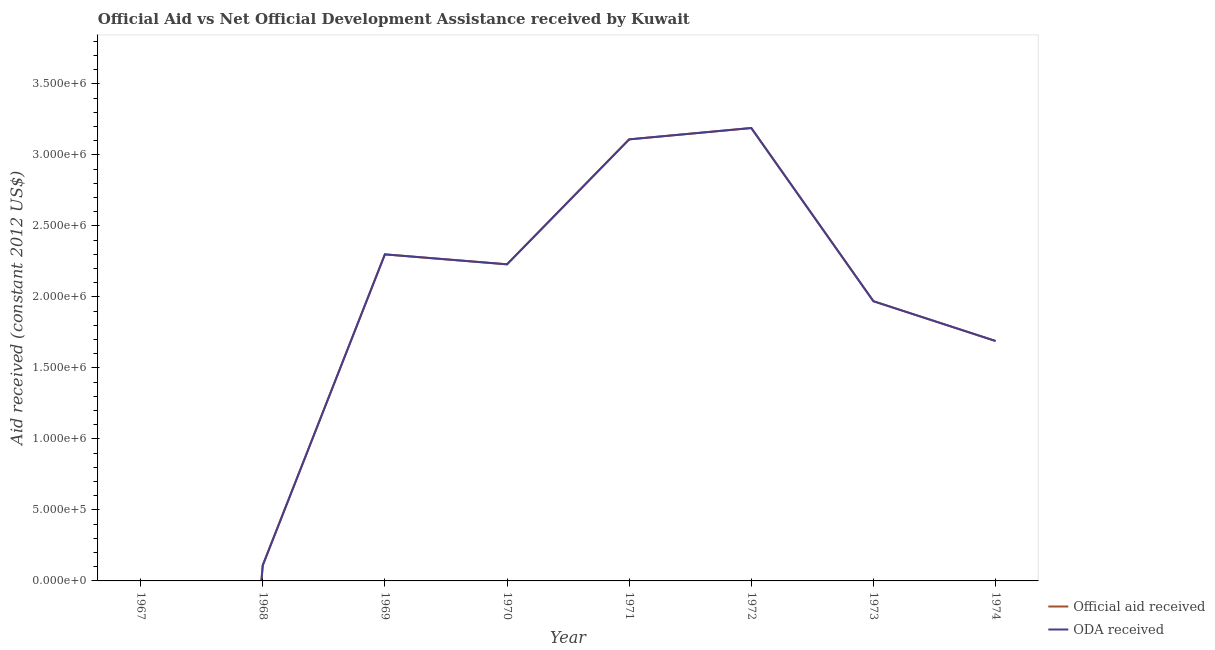How many different coloured lines are there?
Offer a very short reply. 2. Does the line corresponding to official aid received intersect with the line corresponding to oda received?
Offer a terse response. Yes. What is the official aid received in 1972?
Provide a succinct answer. 3.19e+06. Across all years, what is the maximum oda received?
Offer a terse response. 3.19e+06. Across all years, what is the minimum oda received?
Offer a terse response. 0. In which year was the official aid received maximum?
Keep it short and to the point. 1972. What is the total official aid received in the graph?
Your answer should be compact. 1.46e+07. What is the difference between the official aid received in 1970 and that in 1971?
Give a very brief answer. -8.80e+05. What is the difference between the oda received in 1974 and the official aid received in 1972?
Your response must be concise. -1.50e+06. What is the average oda received per year?
Ensure brevity in your answer.  1.82e+06. In the year 1970, what is the difference between the oda received and official aid received?
Your answer should be compact. 0. In how many years, is the official aid received greater than 2000000 US$?
Your answer should be very brief. 4. What is the ratio of the official aid received in 1968 to that in 1973?
Offer a terse response. 0.06. Is the official aid received in 1970 less than that in 1974?
Ensure brevity in your answer.  No. Is the difference between the oda received in 1970 and 1973 greater than the difference between the official aid received in 1970 and 1973?
Give a very brief answer. No. What is the difference between the highest and the second highest oda received?
Your answer should be compact. 8.00e+04. What is the difference between the highest and the lowest official aid received?
Your answer should be compact. 3.19e+06. Is the sum of the oda received in 1968 and 1973 greater than the maximum official aid received across all years?
Offer a very short reply. No. Is the official aid received strictly greater than the oda received over the years?
Your answer should be compact. No. How many lines are there?
Your answer should be very brief. 2. How many years are there in the graph?
Your response must be concise. 8. What is the difference between two consecutive major ticks on the Y-axis?
Ensure brevity in your answer.  5.00e+05. Does the graph contain any zero values?
Your answer should be very brief. Yes. Does the graph contain grids?
Your answer should be compact. No. Where does the legend appear in the graph?
Your answer should be very brief. Bottom right. How many legend labels are there?
Offer a terse response. 2. How are the legend labels stacked?
Make the answer very short. Vertical. What is the title of the graph?
Provide a succinct answer. Official Aid vs Net Official Development Assistance received by Kuwait . What is the label or title of the X-axis?
Offer a very short reply. Year. What is the label or title of the Y-axis?
Keep it short and to the point. Aid received (constant 2012 US$). What is the Aid received (constant 2012 US$) of Official aid received in 1967?
Offer a terse response. 0. What is the Aid received (constant 2012 US$) of Official aid received in 1969?
Make the answer very short. 2.30e+06. What is the Aid received (constant 2012 US$) in ODA received in 1969?
Offer a terse response. 2.30e+06. What is the Aid received (constant 2012 US$) of Official aid received in 1970?
Your answer should be very brief. 2.23e+06. What is the Aid received (constant 2012 US$) of ODA received in 1970?
Offer a terse response. 2.23e+06. What is the Aid received (constant 2012 US$) in Official aid received in 1971?
Keep it short and to the point. 3.11e+06. What is the Aid received (constant 2012 US$) in ODA received in 1971?
Ensure brevity in your answer.  3.11e+06. What is the Aid received (constant 2012 US$) in Official aid received in 1972?
Keep it short and to the point. 3.19e+06. What is the Aid received (constant 2012 US$) in ODA received in 1972?
Provide a short and direct response. 3.19e+06. What is the Aid received (constant 2012 US$) of Official aid received in 1973?
Offer a very short reply. 1.97e+06. What is the Aid received (constant 2012 US$) in ODA received in 1973?
Give a very brief answer. 1.97e+06. What is the Aid received (constant 2012 US$) in Official aid received in 1974?
Your answer should be compact. 1.69e+06. What is the Aid received (constant 2012 US$) of ODA received in 1974?
Keep it short and to the point. 1.69e+06. Across all years, what is the maximum Aid received (constant 2012 US$) in Official aid received?
Keep it short and to the point. 3.19e+06. Across all years, what is the maximum Aid received (constant 2012 US$) of ODA received?
Ensure brevity in your answer.  3.19e+06. Across all years, what is the minimum Aid received (constant 2012 US$) in ODA received?
Offer a very short reply. 0. What is the total Aid received (constant 2012 US$) in Official aid received in the graph?
Give a very brief answer. 1.46e+07. What is the total Aid received (constant 2012 US$) in ODA received in the graph?
Your answer should be compact. 1.46e+07. What is the difference between the Aid received (constant 2012 US$) in Official aid received in 1968 and that in 1969?
Give a very brief answer. -2.19e+06. What is the difference between the Aid received (constant 2012 US$) of ODA received in 1968 and that in 1969?
Your answer should be very brief. -2.19e+06. What is the difference between the Aid received (constant 2012 US$) in Official aid received in 1968 and that in 1970?
Make the answer very short. -2.12e+06. What is the difference between the Aid received (constant 2012 US$) of ODA received in 1968 and that in 1970?
Make the answer very short. -2.12e+06. What is the difference between the Aid received (constant 2012 US$) of Official aid received in 1968 and that in 1971?
Keep it short and to the point. -3.00e+06. What is the difference between the Aid received (constant 2012 US$) in ODA received in 1968 and that in 1971?
Offer a very short reply. -3.00e+06. What is the difference between the Aid received (constant 2012 US$) in Official aid received in 1968 and that in 1972?
Provide a short and direct response. -3.08e+06. What is the difference between the Aid received (constant 2012 US$) of ODA received in 1968 and that in 1972?
Your answer should be very brief. -3.08e+06. What is the difference between the Aid received (constant 2012 US$) of Official aid received in 1968 and that in 1973?
Your answer should be compact. -1.86e+06. What is the difference between the Aid received (constant 2012 US$) of ODA received in 1968 and that in 1973?
Provide a succinct answer. -1.86e+06. What is the difference between the Aid received (constant 2012 US$) of Official aid received in 1968 and that in 1974?
Make the answer very short. -1.58e+06. What is the difference between the Aid received (constant 2012 US$) in ODA received in 1968 and that in 1974?
Make the answer very short. -1.58e+06. What is the difference between the Aid received (constant 2012 US$) of Official aid received in 1969 and that in 1970?
Your answer should be very brief. 7.00e+04. What is the difference between the Aid received (constant 2012 US$) of ODA received in 1969 and that in 1970?
Keep it short and to the point. 7.00e+04. What is the difference between the Aid received (constant 2012 US$) in Official aid received in 1969 and that in 1971?
Offer a very short reply. -8.10e+05. What is the difference between the Aid received (constant 2012 US$) of ODA received in 1969 and that in 1971?
Ensure brevity in your answer.  -8.10e+05. What is the difference between the Aid received (constant 2012 US$) of Official aid received in 1969 and that in 1972?
Provide a short and direct response. -8.90e+05. What is the difference between the Aid received (constant 2012 US$) of ODA received in 1969 and that in 1972?
Your answer should be very brief. -8.90e+05. What is the difference between the Aid received (constant 2012 US$) of Official aid received in 1969 and that in 1973?
Your answer should be very brief. 3.30e+05. What is the difference between the Aid received (constant 2012 US$) of ODA received in 1969 and that in 1973?
Your response must be concise. 3.30e+05. What is the difference between the Aid received (constant 2012 US$) in ODA received in 1969 and that in 1974?
Provide a short and direct response. 6.10e+05. What is the difference between the Aid received (constant 2012 US$) in Official aid received in 1970 and that in 1971?
Offer a very short reply. -8.80e+05. What is the difference between the Aid received (constant 2012 US$) of ODA received in 1970 and that in 1971?
Provide a succinct answer. -8.80e+05. What is the difference between the Aid received (constant 2012 US$) in Official aid received in 1970 and that in 1972?
Provide a succinct answer. -9.60e+05. What is the difference between the Aid received (constant 2012 US$) of ODA received in 1970 and that in 1972?
Offer a terse response. -9.60e+05. What is the difference between the Aid received (constant 2012 US$) of Official aid received in 1970 and that in 1974?
Keep it short and to the point. 5.40e+05. What is the difference between the Aid received (constant 2012 US$) in ODA received in 1970 and that in 1974?
Provide a short and direct response. 5.40e+05. What is the difference between the Aid received (constant 2012 US$) of Official aid received in 1971 and that in 1972?
Keep it short and to the point. -8.00e+04. What is the difference between the Aid received (constant 2012 US$) of ODA received in 1971 and that in 1972?
Your answer should be compact. -8.00e+04. What is the difference between the Aid received (constant 2012 US$) in Official aid received in 1971 and that in 1973?
Offer a very short reply. 1.14e+06. What is the difference between the Aid received (constant 2012 US$) of ODA received in 1971 and that in 1973?
Make the answer very short. 1.14e+06. What is the difference between the Aid received (constant 2012 US$) of Official aid received in 1971 and that in 1974?
Offer a terse response. 1.42e+06. What is the difference between the Aid received (constant 2012 US$) of ODA received in 1971 and that in 1974?
Offer a very short reply. 1.42e+06. What is the difference between the Aid received (constant 2012 US$) in Official aid received in 1972 and that in 1973?
Provide a succinct answer. 1.22e+06. What is the difference between the Aid received (constant 2012 US$) of ODA received in 1972 and that in 1973?
Offer a terse response. 1.22e+06. What is the difference between the Aid received (constant 2012 US$) in Official aid received in 1972 and that in 1974?
Give a very brief answer. 1.50e+06. What is the difference between the Aid received (constant 2012 US$) in ODA received in 1972 and that in 1974?
Ensure brevity in your answer.  1.50e+06. What is the difference between the Aid received (constant 2012 US$) in Official aid received in 1968 and the Aid received (constant 2012 US$) in ODA received in 1969?
Keep it short and to the point. -2.19e+06. What is the difference between the Aid received (constant 2012 US$) in Official aid received in 1968 and the Aid received (constant 2012 US$) in ODA received in 1970?
Your answer should be compact. -2.12e+06. What is the difference between the Aid received (constant 2012 US$) in Official aid received in 1968 and the Aid received (constant 2012 US$) in ODA received in 1972?
Your answer should be compact. -3.08e+06. What is the difference between the Aid received (constant 2012 US$) in Official aid received in 1968 and the Aid received (constant 2012 US$) in ODA received in 1973?
Provide a succinct answer. -1.86e+06. What is the difference between the Aid received (constant 2012 US$) of Official aid received in 1968 and the Aid received (constant 2012 US$) of ODA received in 1974?
Ensure brevity in your answer.  -1.58e+06. What is the difference between the Aid received (constant 2012 US$) of Official aid received in 1969 and the Aid received (constant 2012 US$) of ODA received in 1971?
Provide a short and direct response. -8.10e+05. What is the difference between the Aid received (constant 2012 US$) in Official aid received in 1969 and the Aid received (constant 2012 US$) in ODA received in 1972?
Your answer should be compact. -8.90e+05. What is the difference between the Aid received (constant 2012 US$) in Official aid received in 1970 and the Aid received (constant 2012 US$) in ODA received in 1971?
Your answer should be compact. -8.80e+05. What is the difference between the Aid received (constant 2012 US$) in Official aid received in 1970 and the Aid received (constant 2012 US$) in ODA received in 1972?
Keep it short and to the point. -9.60e+05. What is the difference between the Aid received (constant 2012 US$) in Official aid received in 1970 and the Aid received (constant 2012 US$) in ODA received in 1973?
Your response must be concise. 2.60e+05. What is the difference between the Aid received (constant 2012 US$) in Official aid received in 1970 and the Aid received (constant 2012 US$) in ODA received in 1974?
Offer a terse response. 5.40e+05. What is the difference between the Aid received (constant 2012 US$) of Official aid received in 1971 and the Aid received (constant 2012 US$) of ODA received in 1972?
Provide a succinct answer. -8.00e+04. What is the difference between the Aid received (constant 2012 US$) of Official aid received in 1971 and the Aid received (constant 2012 US$) of ODA received in 1973?
Your answer should be very brief. 1.14e+06. What is the difference between the Aid received (constant 2012 US$) in Official aid received in 1971 and the Aid received (constant 2012 US$) in ODA received in 1974?
Make the answer very short. 1.42e+06. What is the difference between the Aid received (constant 2012 US$) of Official aid received in 1972 and the Aid received (constant 2012 US$) of ODA received in 1973?
Your answer should be very brief. 1.22e+06. What is the difference between the Aid received (constant 2012 US$) in Official aid received in 1972 and the Aid received (constant 2012 US$) in ODA received in 1974?
Your response must be concise. 1.50e+06. What is the difference between the Aid received (constant 2012 US$) of Official aid received in 1973 and the Aid received (constant 2012 US$) of ODA received in 1974?
Ensure brevity in your answer.  2.80e+05. What is the average Aid received (constant 2012 US$) of Official aid received per year?
Offer a terse response. 1.82e+06. What is the average Aid received (constant 2012 US$) in ODA received per year?
Keep it short and to the point. 1.82e+06. In the year 1968, what is the difference between the Aid received (constant 2012 US$) in Official aid received and Aid received (constant 2012 US$) in ODA received?
Provide a succinct answer. 0. In the year 1969, what is the difference between the Aid received (constant 2012 US$) of Official aid received and Aid received (constant 2012 US$) of ODA received?
Provide a short and direct response. 0. In the year 1970, what is the difference between the Aid received (constant 2012 US$) of Official aid received and Aid received (constant 2012 US$) of ODA received?
Your answer should be very brief. 0. In the year 1971, what is the difference between the Aid received (constant 2012 US$) of Official aid received and Aid received (constant 2012 US$) of ODA received?
Provide a short and direct response. 0. What is the ratio of the Aid received (constant 2012 US$) of Official aid received in 1968 to that in 1969?
Provide a short and direct response. 0.05. What is the ratio of the Aid received (constant 2012 US$) in ODA received in 1968 to that in 1969?
Your response must be concise. 0.05. What is the ratio of the Aid received (constant 2012 US$) of Official aid received in 1968 to that in 1970?
Ensure brevity in your answer.  0.05. What is the ratio of the Aid received (constant 2012 US$) of ODA received in 1968 to that in 1970?
Keep it short and to the point. 0.05. What is the ratio of the Aid received (constant 2012 US$) of Official aid received in 1968 to that in 1971?
Provide a short and direct response. 0.04. What is the ratio of the Aid received (constant 2012 US$) in ODA received in 1968 to that in 1971?
Give a very brief answer. 0.04. What is the ratio of the Aid received (constant 2012 US$) in Official aid received in 1968 to that in 1972?
Your answer should be very brief. 0.03. What is the ratio of the Aid received (constant 2012 US$) of ODA received in 1968 to that in 1972?
Offer a terse response. 0.03. What is the ratio of the Aid received (constant 2012 US$) in Official aid received in 1968 to that in 1973?
Ensure brevity in your answer.  0.06. What is the ratio of the Aid received (constant 2012 US$) of ODA received in 1968 to that in 1973?
Provide a succinct answer. 0.06. What is the ratio of the Aid received (constant 2012 US$) in Official aid received in 1968 to that in 1974?
Offer a terse response. 0.07. What is the ratio of the Aid received (constant 2012 US$) of ODA received in 1968 to that in 1974?
Offer a terse response. 0.07. What is the ratio of the Aid received (constant 2012 US$) in Official aid received in 1969 to that in 1970?
Keep it short and to the point. 1.03. What is the ratio of the Aid received (constant 2012 US$) of ODA received in 1969 to that in 1970?
Your answer should be compact. 1.03. What is the ratio of the Aid received (constant 2012 US$) in Official aid received in 1969 to that in 1971?
Make the answer very short. 0.74. What is the ratio of the Aid received (constant 2012 US$) of ODA received in 1969 to that in 1971?
Give a very brief answer. 0.74. What is the ratio of the Aid received (constant 2012 US$) in Official aid received in 1969 to that in 1972?
Your answer should be compact. 0.72. What is the ratio of the Aid received (constant 2012 US$) in ODA received in 1969 to that in 1972?
Your answer should be very brief. 0.72. What is the ratio of the Aid received (constant 2012 US$) in Official aid received in 1969 to that in 1973?
Provide a short and direct response. 1.17. What is the ratio of the Aid received (constant 2012 US$) of ODA received in 1969 to that in 1973?
Give a very brief answer. 1.17. What is the ratio of the Aid received (constant 2012 US$) of Official aid received in 1969 to that in 1974?
Your answer should be very brief. 1.36. What is the ratio of the Aid received (constant 2012 US$) in ODA received in 1969 to that in 1974?
Keep it short and to the point. 1.36. What is the ratio of the Aid received (constant 2012 US$) of Official aid received in 1970 to that in 1971?
Ensure brevity in your answer.  0.72. What is the ratio of the Aid received (constant 2012 US$) in ODA received in 1970 to that in 1971?
Your answer should be compact. 0.72. What is the ratio of the Aid received (constant 2012 US$) in Official aid received in 1970 to that in 1972?
Give a very brief answer. 0.7. What is the ratio of the Aid received (constant 2012 US$) of ODA received in 1970 to that in 1972?
Ensure brevity in your answer.  0.7. What is the ratio of the Aid received (constant 2012 US$) of Official aid received in 1970 to that in 1973?
Keep it short and to the point. 1.13. What is the ratio of the Aid received (constant 2012 US$) of ODA received in 1970 to that in 1973?
Give a very brief answer. 1.13. What is the ratio of the Aid received (constant 2012 US$) of Official aid received in 1970 to that in 1974?
Offer a terse response. 1.32. What is the ratio of the Aid received (constant 2012 US$) in ODA received in 1970 to that in 1974?
Make the answer very short. 1.32. What is the ratio of the Aid received (constant 2012 US$) in Official aid received in 1971 to that in 1972?
Ensure brevity in your answer.  0.97. What is the ratio of the Aid received (constant 2012 US$) of ODA received in 1971 to that in 1972?
Your response must be concise. 0.97. What is the ratio of the Aid received (constant 2012 US$) of Official aid received in 1971 to that in 1973?
Give a very brief answer. 1.58. What is the ratio of the Aid received (constant 2012 US$) in ODA received in 1971 to that in 1973?
Offer a terse response. 1.58. What is the ratio of the Aid received (constant 2012 US$) in Official aid received in 1971 to that in 1974?
Your response must be concise. 1.84. What is the ratio of the Aid received (constant 2012 US$) in ODA received in 1971 to that in 1974?
Keep it short and to the point. 1.84. What is the ratio of the Aid received (constant 2012 US$) in Official aid received in 1972 to that in 1973?
Provide a short and direct response. 1.62. What is the ratio of the Aid received (constant 2012 US$) in ODA received in 1972 to that in 1973?
Provide a succinct answer. 1.62. What is the ratio of the Aid received (constant 2012 US$) in Official aid received in 1972 to that in 1974?
Provide a succinct answer. 1.89. What is the ratio of the Aid received (constant 2012 US$) in ODA received in 1972 to that in 1974?
Offer a very short reply. 1.89. What is the ratio of the Aid received (constant 2012 US$) of Official aid received in 1973 to that in 1974?
Your response must be concise. 1.17. What is the ratio of the Aid received (constant 2012 US$) of ODA received in 1973 to that in 1974?
Your answer should be very brief. 1.17. What is the difference between the highest and the second highest Aid received (constant 2012 US$) in Official aid received?
Ensure brevity in your answer.  8.00e+04. What is the difference between the highest and the lowest Aid received (constant 2012 US$) of Official aid received?
Your answer should be compact. 3.19e+06. What is the difference between the highest and the lowest Aid received (constant 2012 US$) of ODA received?
Your response must be concise. 3.19e+06. 